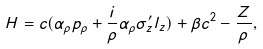Convert formula to latex. <formula><loc_0><loc_0><loc_500><loc_500>H = c ( \alpha _ { \rho } p _ { \rho } + \frac { i } { \rho } \alpha _ { \rho } \sigma ^ { \prime } _ { z } l _ { z } ) + \beta c ^ { 2 } - \frac { Z } { \rho } ,</formula> 